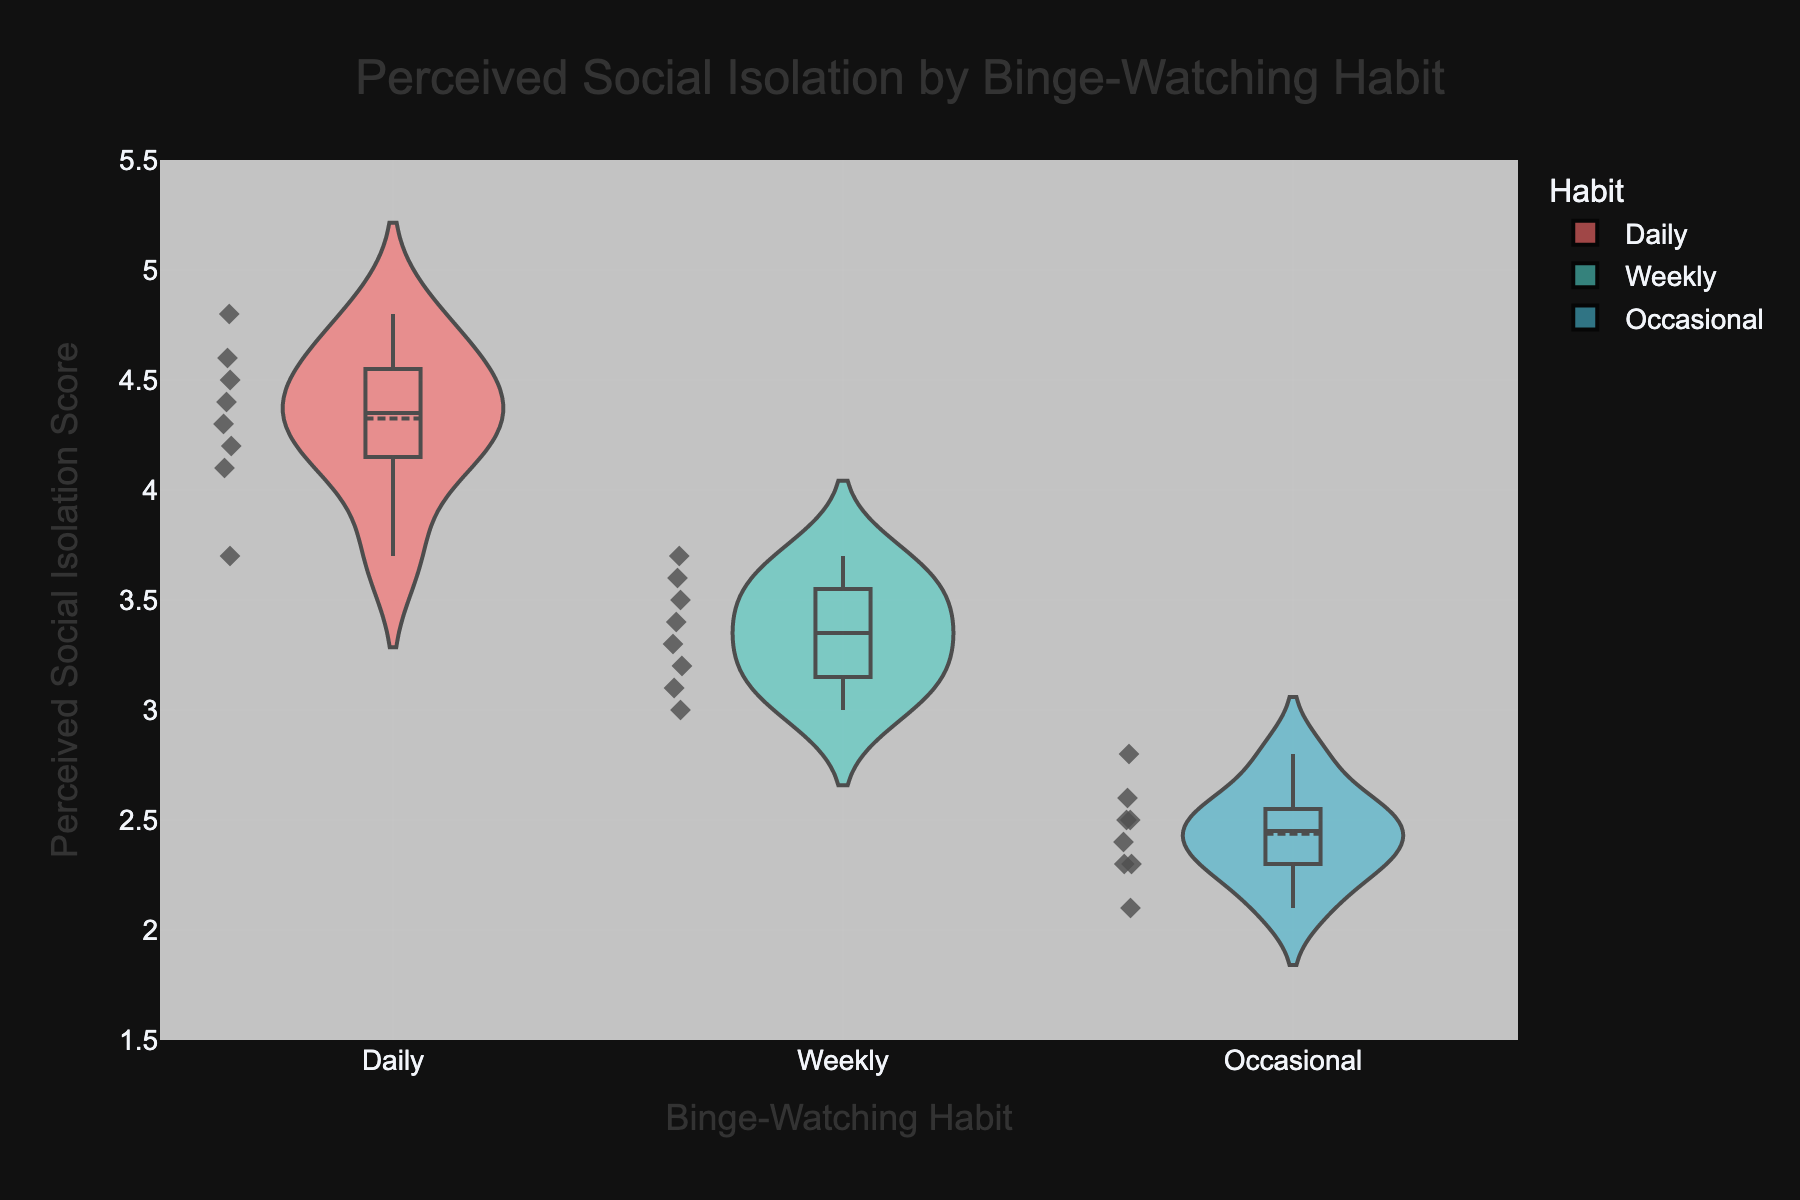What is the title of the violin plot? The title is displayed at the top of the figure, which summarizes what the plot is about.
Answer: Perceived Social Isolation by Binge-Watching Habit What are the categories on the x-axis? The x-axis shows the different binge-watching habits of individuals, indicated by their labels.
Answer: Daily, Weekly, Occasional What is the range of the y-axis? The y-axis shows the perceived social isolation scores which range from 1.5 to 5.5. This can be observed by looking at the y-axis ticks and labels.
Answer: 1.5 to 5.5 What is the mean perceived social isolation score for daily binge-watchers? The mean score is visible as a line inside the violin representing the daily binge-watching habit.
Answer: ~4.3 Which group has the highest perception of social isolation? By comparing the heights of the colored areas (violins), we can identify that daily binge-watchers have the highest perceived social isolation.
Answer: Daily Which group has the lowest median perceived social isolation score? The median is shown as a dashed line inside the violins. By comparing these lines across groups, we see that occasional binge-watchers have the lowest median score.
Answer: Occasional How does the distribution of perceived social isolation scores in weekly binge-watchers compare to occasional binge-watchers? The distribution for weekly binge-watchers covers a higher range of scores (around 3.0 to 3.7), whereas occasional ranges from (around 2.1 to 2.8). The weekly binge-watchers show a slightly wider and higher spread of scores.
Answer: Higher and wider What are the maximum and minimum perceived social isolation scores for daily binge-watchers? The maximum and minimum values are shown as the outer edges of the violin plot for the daily binge-watchers group.
Answer: Max: 4.8, Min: 3.7 Which group's perceived social isolation score has the smallest interquartile range? The interquartile range is visible as the range between the two horizontal lines in the box inside the violin. The occasional binge-watchers have the smallest interquartile range.
Answer: Occasional 